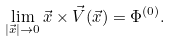Convert formula to latex. <formula><loc_0><loc_0><loc_500><loc_500>\lim _ { | \vec { x } | \to 0 } \vec { x } \times \vec { V } ( \vec { x } ) = \Phi ^ { ( 0 ) } .</formula> 